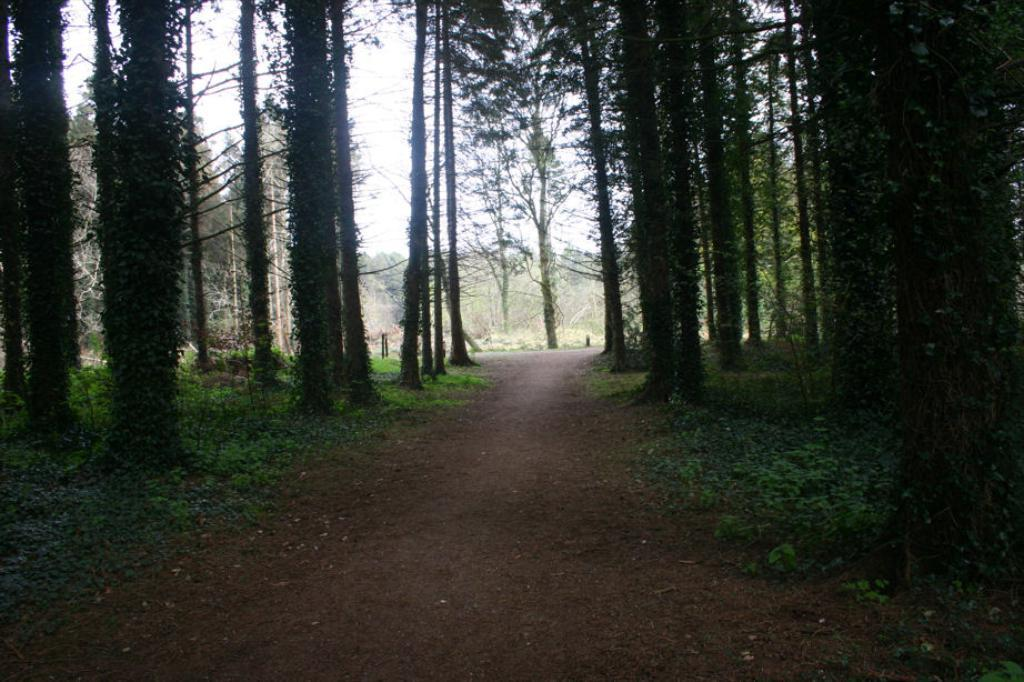What is the main feature in the middle of the image? There is a path in the middle of the image. What type of vegetation is present on either side of the path? Trees are present on either side of the path. What can be seen in the background of the image? The sky is visible in the background of the image. How is the glue being used in the image? There is no glue present in the image. What emotion is being displayed by the trees in the image? Trees do not display emotions, so this question cannot be answered. 